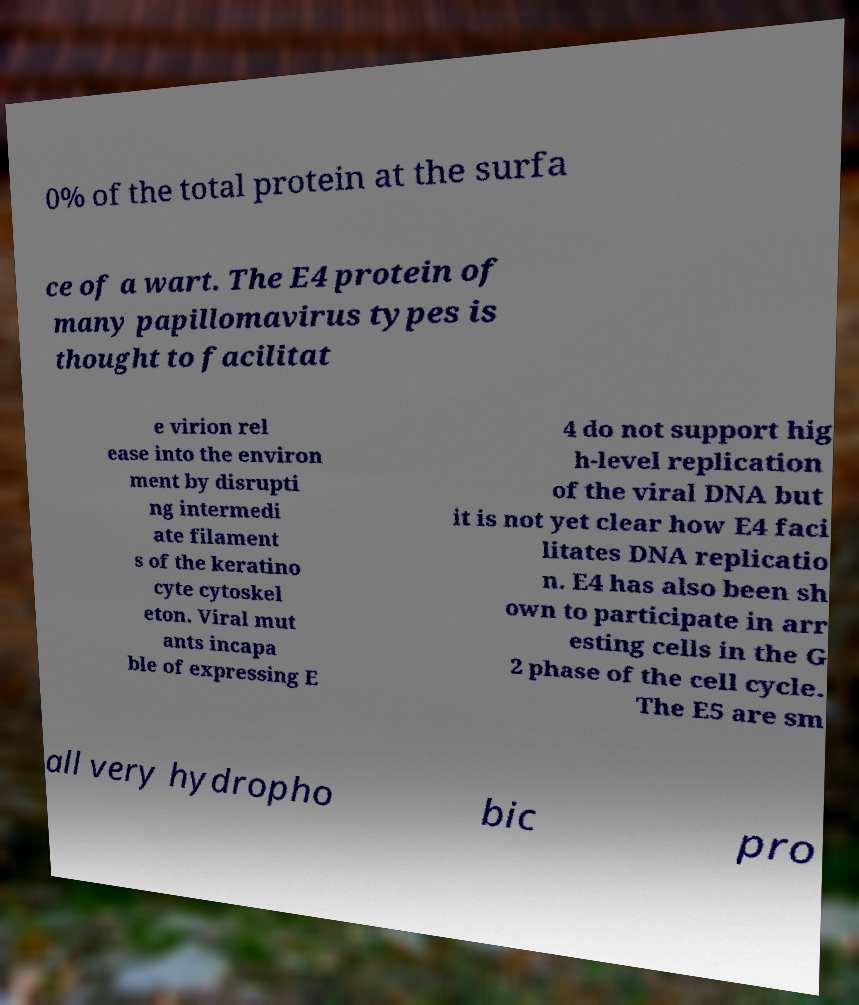Can you accurately transcribe the text from the provided image for me? 0% of the total protein at the surfa ce of a wart. The E4 protein of many papillomavirus types is thought to facilitat e virion rel ease into the environ ment by disrupti ng intermedi ate filament s of the keratino cyte cytoskel eton. Viral mut ants incapa ble of expressing E 4 do not support hig h-level replication of the viral DNA but it is not yet clear how E4 faci litates DNA replicatio n. E4 has also been sh own to participate in arr esting cells in the G 2 phase of the cell cycle. The E5 are sm all very hydropho bic pro 